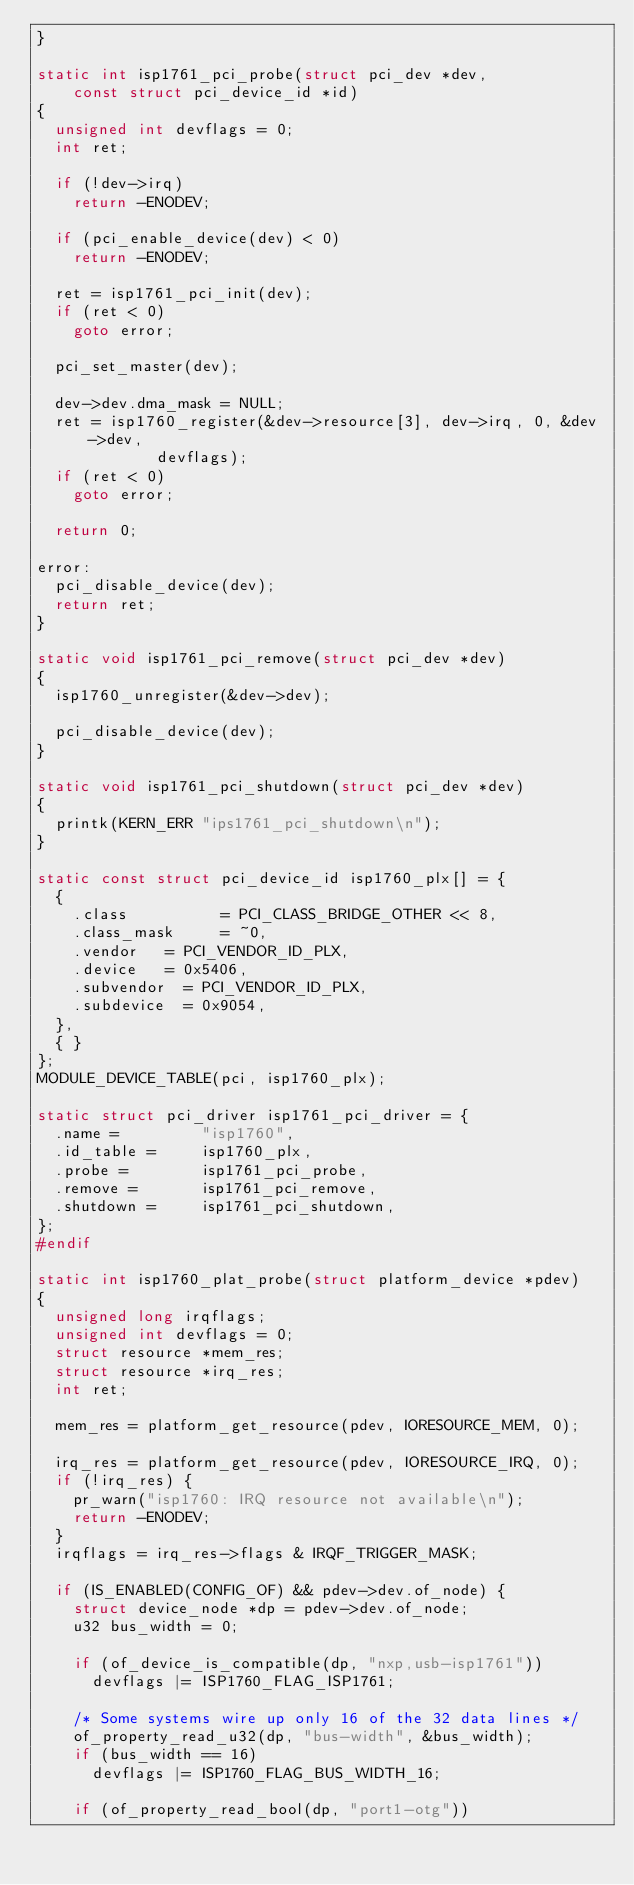<code> <loc_0><loc_0><loc_500><loc_500><_C_>}

static int isp1761_pci_probe(struct pci_dev *dev,
		const struct pci_device_id *id)
{
	unsigned int devflags = 0;
	int ret;

	if (!dev->irq)
		return -ENODEV;

	if (pci_enable_device(dev) < 0)
		return -ENODEV;

	ret = isp1761_pci_init(dev);
	if (ret < 0)
		goto error;

	pci_set_master(dev);

	dev->dev.dma_mask = NULL;
	ret = isp1760_register(&dev->resource[3], dev->irq, 0, &dev->dev,
			       devflags);
	if (ret < 0)
		goto error;

	return 0;

error:
	pci_disable_device(dev);
	return ret;
}

static void isp1761_pci_remove(struct pci_dev *dev)
{
	isp1760_unregister(&dev->dev);

	pci_disable_device(dev);
}

static void isp1761_pci_shutdown(struct pci_dev *dev)
{
	printk(KERN_ERR "ips1761_pci_shutdown\n");
}

static const struct pci_device_id isp1760_plx[] = {
	{
		.class          = PCI_CLASS_BRIDGE_OTHER << 8,
		.class_mask     = ~0,
		.vendor		= PCI_VENDOR_ID_PLX,
		.device		= 0x5406,
		.subvendor	= PCI_VENDOR_ID_PLX,
		.subdevice	= 0x9054,
	},
	{ }
};
MODULE_DEVICE_TABLE(pci, isp1760_plx);

static struct pci_driver isp1761_pci_driver = {
	.name =         "isp1760",
	.id_table =     isp1760_plx,
	.probe =        isp1761_pci_probe,
	.remove =       isp1761_pci_remove,
	.shutdown =     isp1761_pci_shutdown,
};
#endif

static int isp1760_plat_probe(struct platform_device *pdev)
{
	unsigned long irqflags;
	unsigned int devflags = 0;
	struct resource *mem_res;
	struct resource *irq_res;
	int ret;

	mem_res = platform_get_resource(pdev, IORESOURCE_MEM, 0);

	irq_res = platform_get_resource(pdev, IORESOURCE_IRQ, 0);
	if (!irq_res) {
		pr_warn("isp1760: IRQ resource not available\n");
		return -ENODEV;
	}
	irqflags = irq_res->flags & IRQF_TRIGGER_MASK;

	if (IS_ENABLED(CONFIG_OF) && pdev->dev.of_node) {
		struct device_node *dp = pdev->dev.of_node;
		u32 bus_width = 0;

		if (of_device_is_compatible(dp, "nxp,usb-isp1761"))
			devflags |= ISP1760_FLAG_ISP1761;

		/* Some systems wire up only 16 of the 32 data lines */
		of_property_read_u32(dp, "bus-width", &bus_width);
		if (bus_width == 16)
			devflags |= ISP1760_FLAG_BUS_WIDTH_16;

		if (of_property_read_bool(dp, "port1-otg"))</code> 